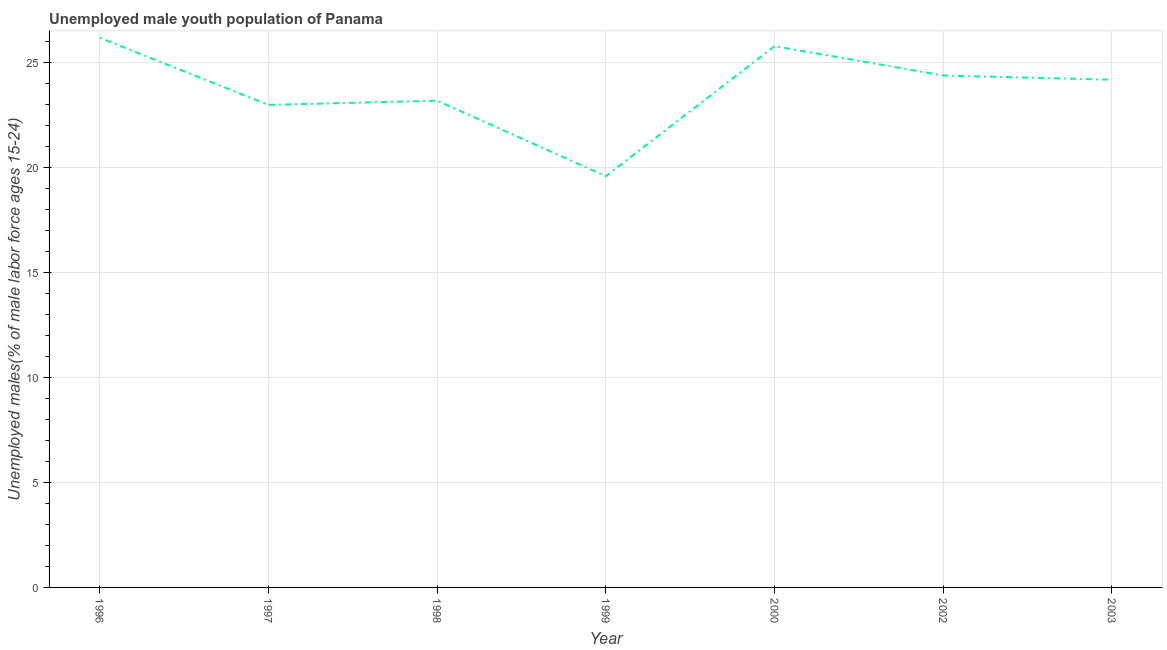What is the unemployed male youth in 1999?
Offer a very short reply. 19.6. Across all years, what is the maximum unemployed male youth?
Make the answer very short. 26.2. Across all years, what is the minimum unemployed male youth?
Your answer should be compact. 19.6. What is the sum of the unemployed male youth?
Offer a terse response. 166.4. What is the difference between the unemployed male youth in 1998 and 1999?
Your response must be concise. 3.6. What is the average unemployed male youth per year?
Ensure brevity in your answer.  23.77. What is the median unemployed male youth?
Offer a very short reply. 24.2. What is the ratio of the unemployed male youth in 1998 to that in 2003?
Make the answer very short. 0.96. Is the difference between the unemployed male youth in 1997 and 1998 greater than the difference between any two years?
Your answer should be very brief. No. What is the difference between the highest and the second highest unemployed male youth?
Your answer should be very brief. 0.4. Is the sum of the unemployed male youth in 1999 and 2000 greater than the maximum unemployed male youth across all years?
Provide a succinct answer. Yes. What is the difference between the highest and the lowest unemployed male youth?
Your answer should be compact. 6.6. In how many years, is the unemployed male youth greater than the average unemployed male youth taken over all years?
Offer a terse response. 4. Does the unemployed male youth monotonically increase over the years?
Your answer should be very brief. No. What is the difference between two consecutive major ticks on the Y-axis?
Ensure brevity in your answer.  5. What is the title of the graph?
Ensure brevity in your answer.  Unemployed male youth population of Panama. What is the label or title of the Y-axis?
Offer a very short reply. Unemployed males(% of male labor force ages 15-24). What is the Unemployed males(% of male labor force ages 15-24) in 1996?
Keep it short and to the point. 26.2. What is the Unemployed males(% of male labor force ages 15-24) of 1997?
Ensure brevity in your answer.  23. What is the Unemployed males(% of male labor force ages 15-24) of 1998?
Make the answer very short. 23.2. What is the Unemployed males(% of male labor force ages 15-24) of 1999?
Provide a succinct answer. 19.6. What is the Unemployed males(% of male labor force ages 15-24) of 2000?
Offer a terse response. 25.8. What is the Unemployed males(% of male labor force ages 15-24) of 2002?
Ensure brevity in your answer.  24.4. What is the Unemployed males(% of male labor force ages 15-24) in 2003?
Provide a short and direct response. 24.2. What is the difference between the Unemployed males(% of male labor force ages 15-24) in 1996 and 1997?
Your response must be concise. 3.2. What is the difference between the Unemployed males(% of male labor force ages 15-24) in 1996 and 1998?
Provide a short and direct response. 3. What is the difference between the Unemployed males(% of male labor force ages 15-24) in 1996 and 1999?
Give a very brief answer. 6.6. What is the difference between the Unemployed males(% of male labor force ages 15-24) in 1996 and 2002?
Make the answer very short. 1.8. What is the difference between the Unemployed males(% of male labor force ages 15-24) in 1997 and 1998?
Give a very brief answer. -0.2. What is the difference between the Unemployed males(% of male labor force ages 15-24) in 1997 and 1999?
Ensure brevity in your answer.  3.4. What is the difference between the Unemployed males(% of male labor force ages 15-24) in 1997 and 2000?
Make the answer very short. -2.8. What is the difference between the Unemployed males(% of male labor force ages 15-24) in 1998 and 1999?
Keep it short and to the point. 3.6. What is the difference between the Unemployed males(% of male labor force ages 15-24) in 1998 and 2002?
Provide a succinct answer. -1.2. What is the difference between the Unemployed males(% of male labor force ages 15-24) in 1998 and 2003?
Your answer should be compact. -1. What is the difference between the Unemployed males(% of male labor force ages 15-24) in 1999 and 2000?
Your answer should be compact. -6.2. What is the difference between the Unemployed males(% of male labor force ages 15-24) in 1999 and 2002?
Your answer should be compact. -4.8. What is the difference between the Unemployed males(% of male labor force ages 15-24) in 1999 and 2003?
Your answer should be compact. -4.6. What is the difference between the Unemployed males(% of male labor force ages 15-24) in 2000 and 2003?
Offer a terse response. 1.6. What is the ratio of the Unemployed males(% of male labor force ages 15-24) in 1996 to that in 1997?
Offer a very short reply. 1.14. What is the ratio of the Unemployed males(% of male labor force ages 15-24) in 1996 to that in 1998?
Provide a short and direct response. 1.13. What is the ratio of the Unemployed males(% of male labor force ages 15-24) in 1996 to that in 1999?
Ensure brevity in your answer.  1.34. What is the ratio of the Unemployed males(% of male labor force ages 15-24) in 1996 to that in 2002?
Offer a very short reply. 1.07. What is the ratio of the Unemployed males(% of male labor force ages 15-24) in 1996 to that in 2003?
Offer a terse response. 1.08. What is the ratio of the Unemployed males(% of male labor force ages 15-24) in 1997 to that in 1998?
Keep it short and to the point. 0.99. What is the ratio of the Unemployed males(% of male labor force ages 15-24) in 1997 to that in 1999?
Make the answer very short. 1.17. What is the ratio of the Unemployed males(% of male labor force ages 15-24) in 1997 to that in 2000?
Your answer should be compact. 0.89. What is the ratio of the Unemployed males(% of male labor force ages 15-24) in 1997 to that in 2002?
Keep it short and to the point. 0.94. What is the ratio of the Unemployed males(% of male labor force ages 15-24) in 1997 to that in 2003?
Make the answer very short. 0.95. What is the ratio of the Unemployed males(% of male labor force ages 15-24) in 1998 to that in 1999?
Provide a short and direct response. 1.18. What is the ratio of the Unemployed males(% of male labor force ages 15-24) in 1998 to that in 2000?
Your answer should be very brief. 0.9. What is the ratio of the Unemployed males(% of male labor force ages 15-24) in 1998 to that in 2002?
Provide a succinct answer. 0.95. What is the ratio of the Unemployed males(% of male labor force ages 15-24) in 1999 to that in 2000?
Your response must be concise. 0.76. What is the ratio of the Unemployed males(% of male labor force ages 15-24) in 1999 to that in 2002?
Provide a succinct answer. 0.8. What is the ratio of the Unemployed males(% of male labor force ages 15-24) in 1999 to that in 2003?
Keep it short and to the point. 0.81. What is the ratio of the Unemployed males(% of male labor force ages 15-24) in 2000 to that in 2002?
Make the answer very short. 1.06. What is the ratio of the Unemployed males(% of male labor force ages 15-24) in 2000 to that in 2003?
Offer a very short reply. 1.07. 